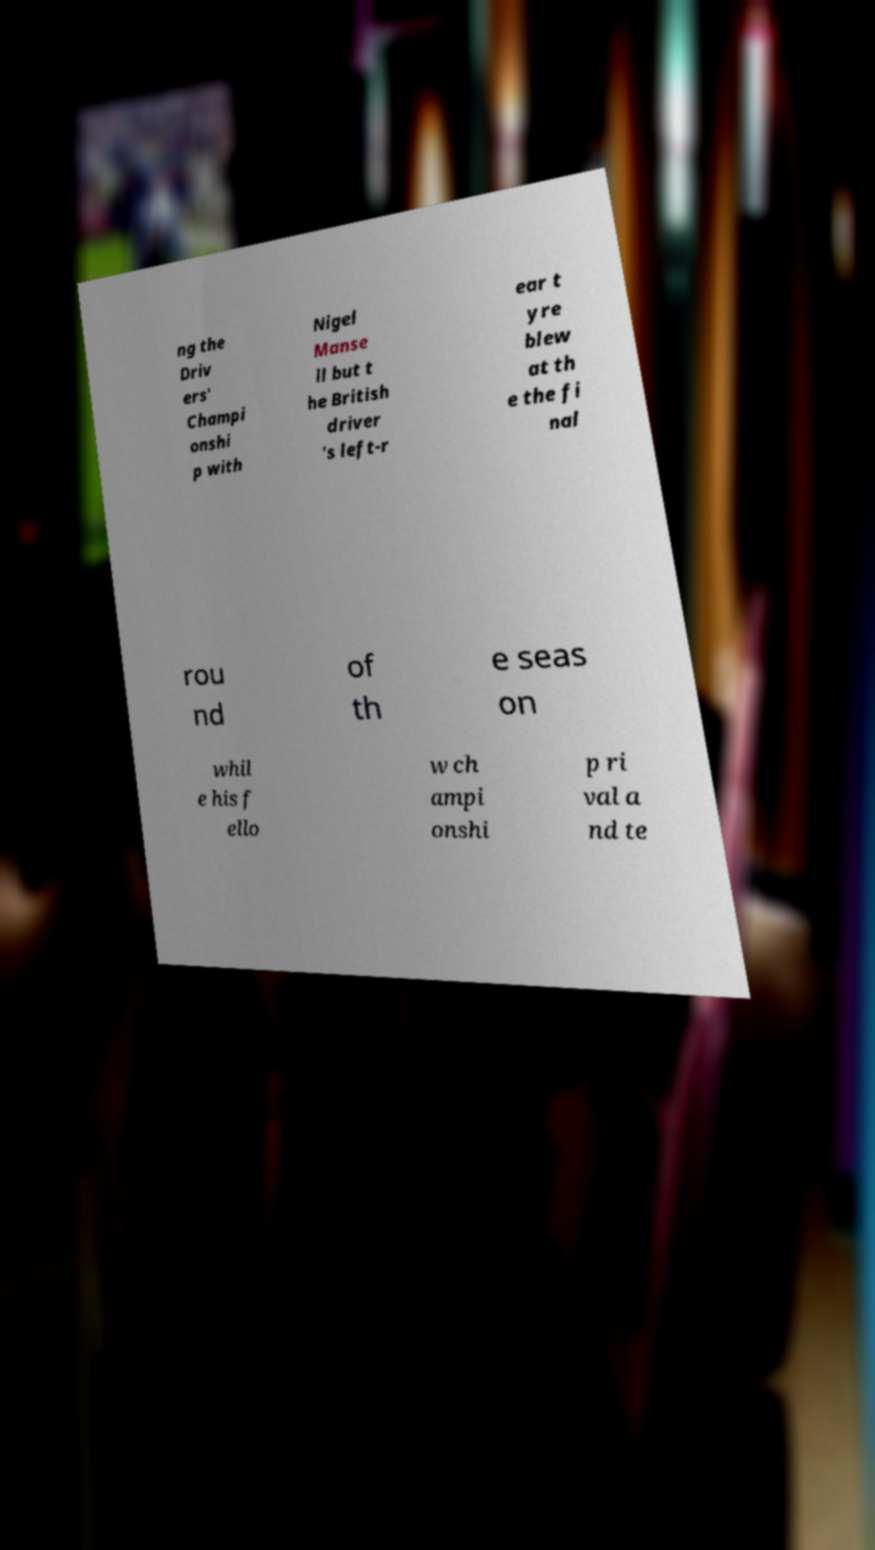I need the written content from this picture converted into text. Can you do that? ng the Driv ers' Champi onshi p with Nigel Manse ll but t he British driver 's left-r ear t yre blew at th e the fi nal rou nd of th e seas on whil e his f ello w ch ampi onshi p ri val a nd te 